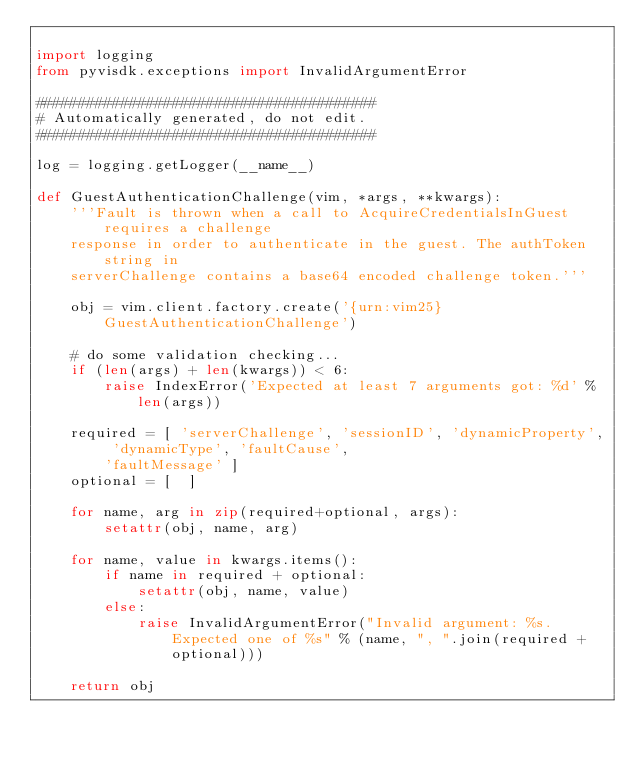<code> <loc_0><loc_0><loc_500><loc_500><_Python_>
import logging
from pyvisdk.exceptions import InvalidArgumentError

########################################
# Automatically generated, do not edit.
########################################

log = logging.getLogger(__name__)

def GuestAuthenticationChallenge(vim, *args, **kwargs):
    '''Fault is thrown when a call to AcquireCredentialsInGuest requires a challenge
    response in order to authenticate in the guest. The authToken string in
    serverChallenge contains a base64 encoded challenge token.'''

    obj = vim.client.factory.create('{urn:vim25}GuestAuthenticationChallenge')

    # do some validation checking...
    if (len(args) + len(kwargs)) < 6:
        raise IndexError('Expected at least 7 arguments got: %d' % len(args))

    required = [ 'serverChallenge', 'sessionID', 'dynamicProperty', 'dynamicType', 'faultCause',
        'faultMessage' ]
    optional = [  ]

    for name, arg in zip(required+optional, args):
        setattr(obj, name, arg)

    for name, value in kwargs.items():
        if name in required + optional:
            setattr(obj, name, value)
        else:
            raise InvalidArgumentError("Invalid argument: %s.  Expected one of %s" % (name, ", ".join(required + optional)))

    return obj
</code> 